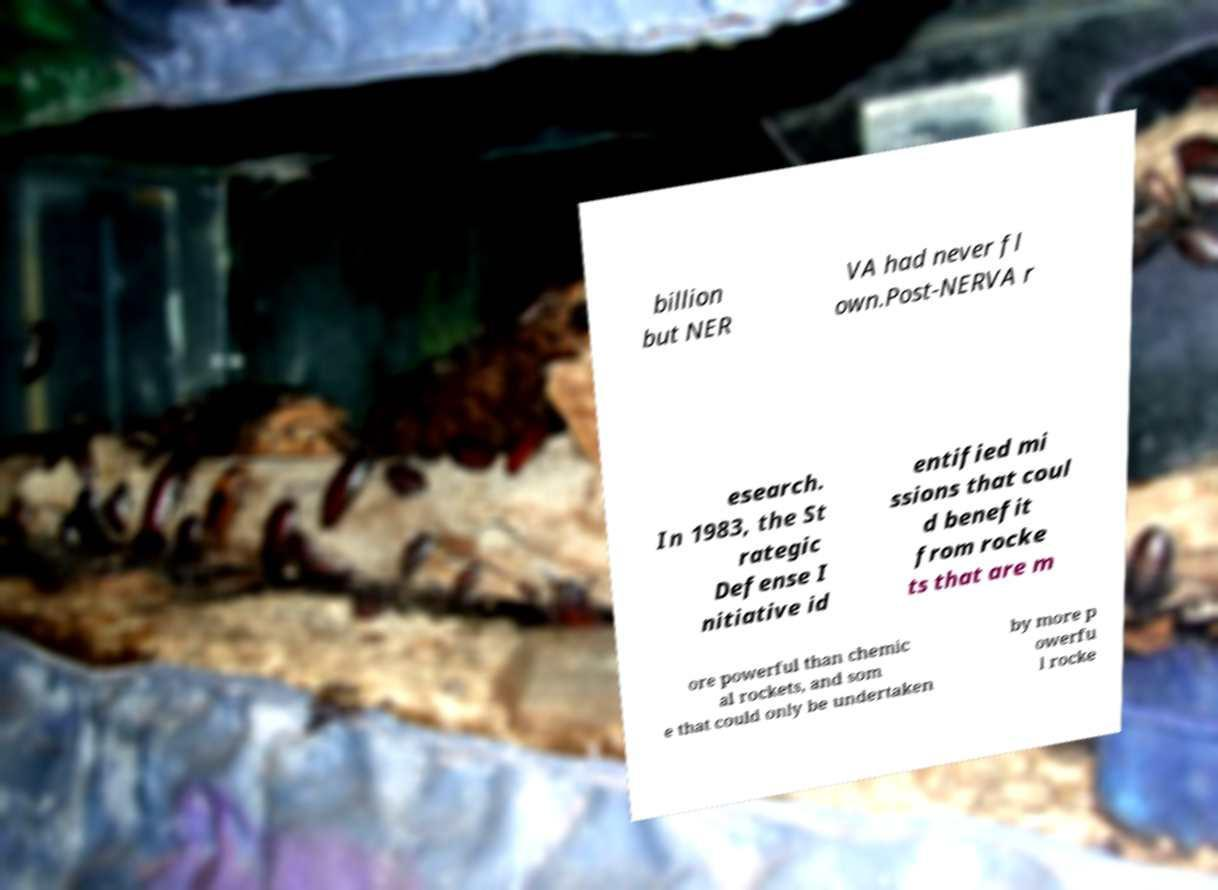Can you accurately transcribe the text from the provided image for me? billion but NER VA had never fl own.Post-NERVA r esearch. In 1983, the St rategic Defense I nitiative id entified mi ssions that coul d benefit from rocke ts that are m ore powerful than chemic al rockets, and som e that could only be undertaken by more p owerfu l rocke 